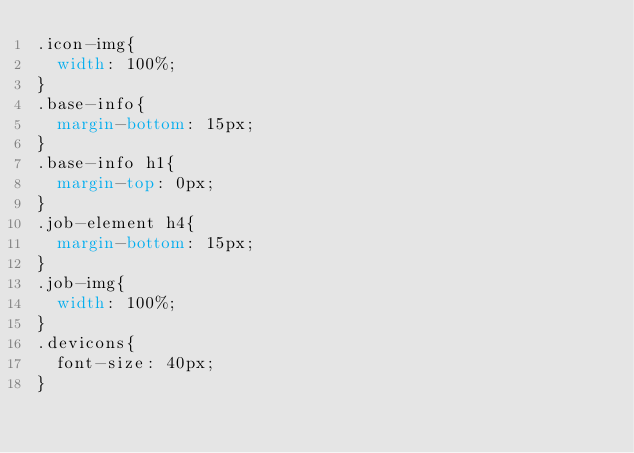<code> <loc_0><loc_0><loc_500><loc_500><_CSS_>.icon-img{
  width: 100%;
}
.base-info{
  margin-bottom: 15px;
}
.base-info h1{
  margin-top: 0px;
}
.job-element h4{
  margin-bottom: 15px;
}
.job-img{
  width: 100%;
}
.devicons{
  font-size: 40px;
}
</code> 